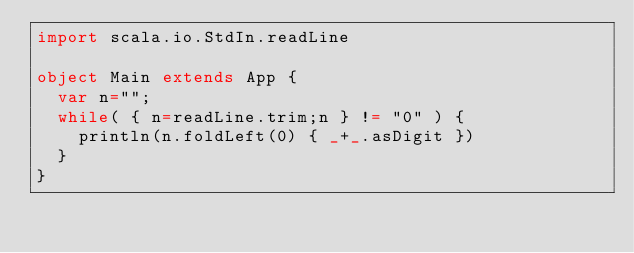<code> <loc_0><loc_0><loc_500><loc_500><_Scala_>import scala.io.StdIn.readLine

object Main extends App {
  var n="";
  while( { n=readLine.trim;n } != "0" ) {
    println(n.foldLeft(0) { _+_.asDigit })
  }
}</code> 